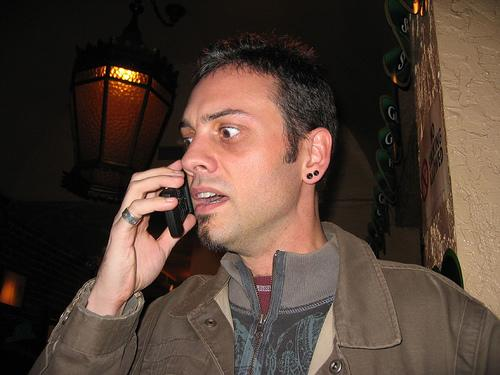What is the position of the man's head and what features can be observed on his face? The man has his head turned, he has black short hair and facial hair. Count the number of objects mentioned in the image description and provide a brief summary of their interactions. There are 8 objects mentioned: the man, the cell phone, the ring, the earrings, the jacket, the shirt, the light, and the no smoking sign. The man is talking on the cell phone, wearing the ring, and the earrings, dressed in the jacket and shirt, and standing near the light and no smoking sign. List three items the man is wearing and describe the color of each one. The man is wearing a brown-colored jacket, a burgundy shirt, and a silver pinky ring. Determine the quality and details of the image based on the given information. The image appears to be detailed with various objects being accurately described, indicating a good quality image. Enumerate the different features related to the man's head and face. Features related to the man's head and face include black short hair, facial hair, pierced ears with black earrings, and a light skin tone. What color is the man's jacket and what activity is he engaged in? The man's jacket is brown and he is engaged in talking on a black cell phone. Analyze the general sentiment of the image based on the description. The general sentiment of the image is neutral, as the man is simply using a cell phone and wearing various clothing items and accessories. Provide a detailed description of the man in the image. The man is light-skinned with black short hair, facial hair, and pierced ears with black earrings. He is wearing a brown jacket, a burgundy shirt, a silver pinky ring, and has his head turned while using a black cell phone. Describe the man's hand position and which finger he is wearing a ring on. The man's hand is holding a phone and he is wearing a silver ring on his pinky finger. Identify the color and shape of the object in the background. There is a lantern-shaped light in the background that is turned on. 